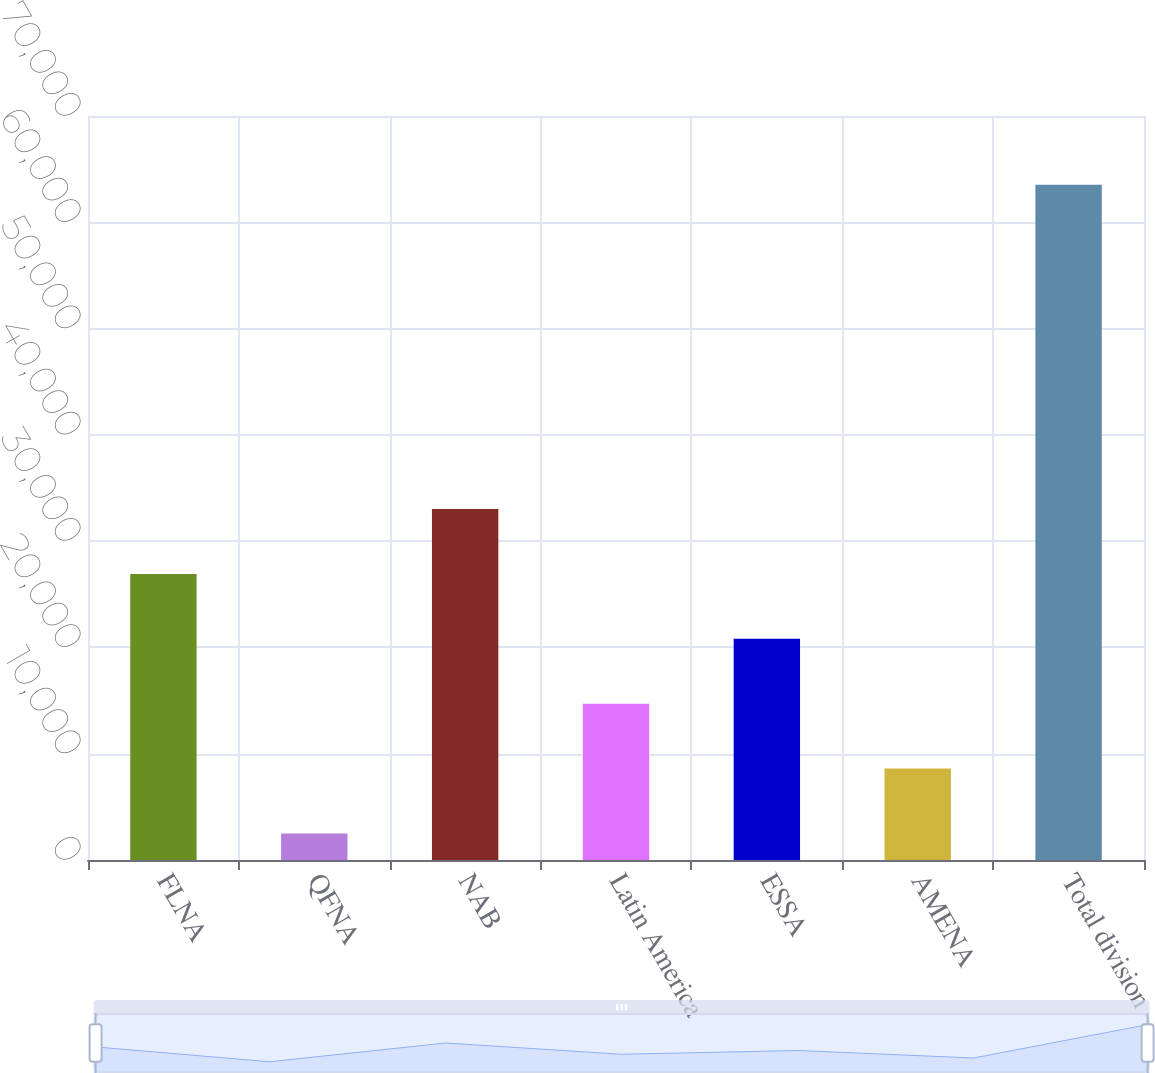<chart> <loc_0><loc_0><loc_500><loc_500><bar_chart><fcel>FLNA<fcel>QFNA<fcel>NAB<fcel>Latin America<fcel>ESSA<fcel>AMENA<fcel>Total division<nl><fcel>26911.8<fcel>2503<fcel>33014<fcel>14707.4<fcel>20809.6<fcel>8605.2<fcel>63525<nl></chart> 